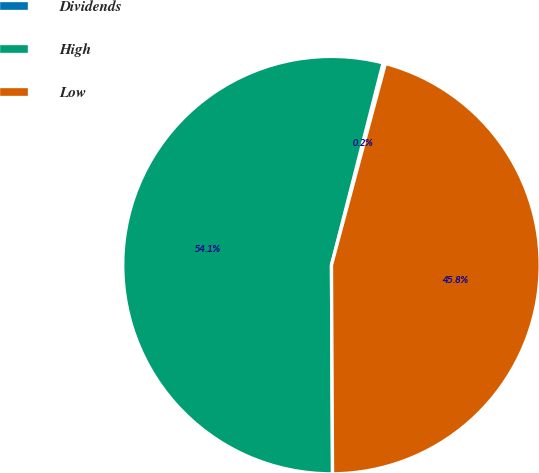Convert chart. <chart><loc_0><loc_0><loc_500><loc_500><pie_chart><fcel>Dividends<fcel>High<fcel>Low<nl><fcel>0.18%<fcel>54.06%<fcel>45.76%<nl></chart> 